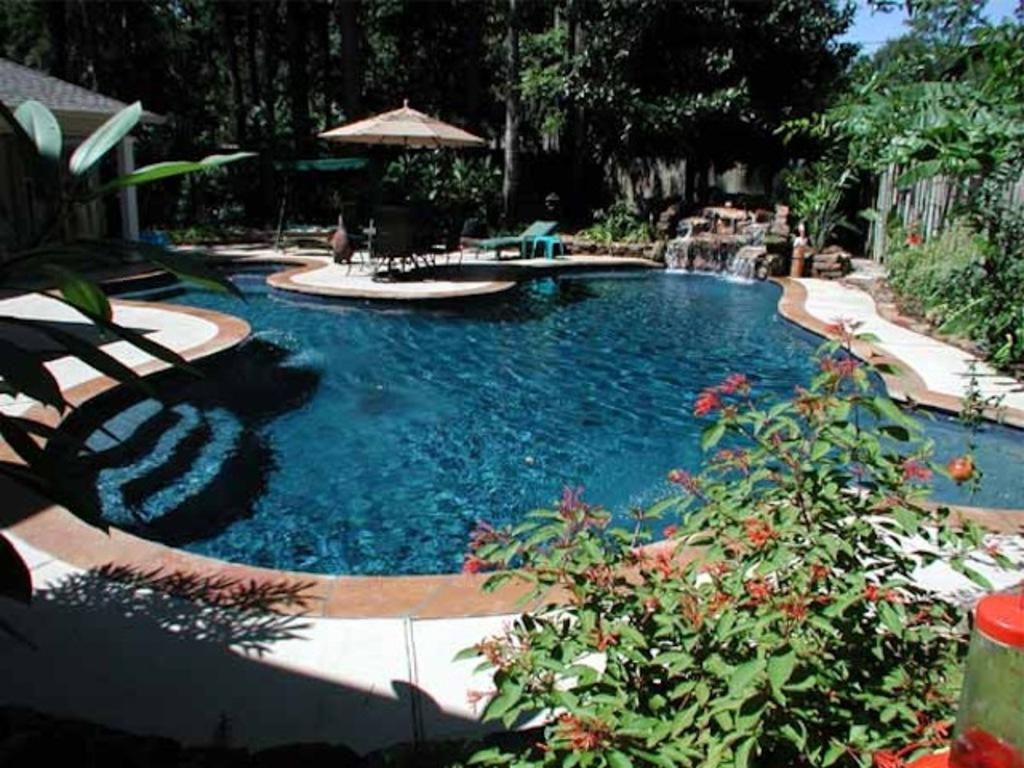Please provide a concise description of this image. In this image we can see the pool, beach bed, chairs and also an umbrella for shelter. We can also see the roof on the left. We can see the path, plants, trees, fence and also the sky. 